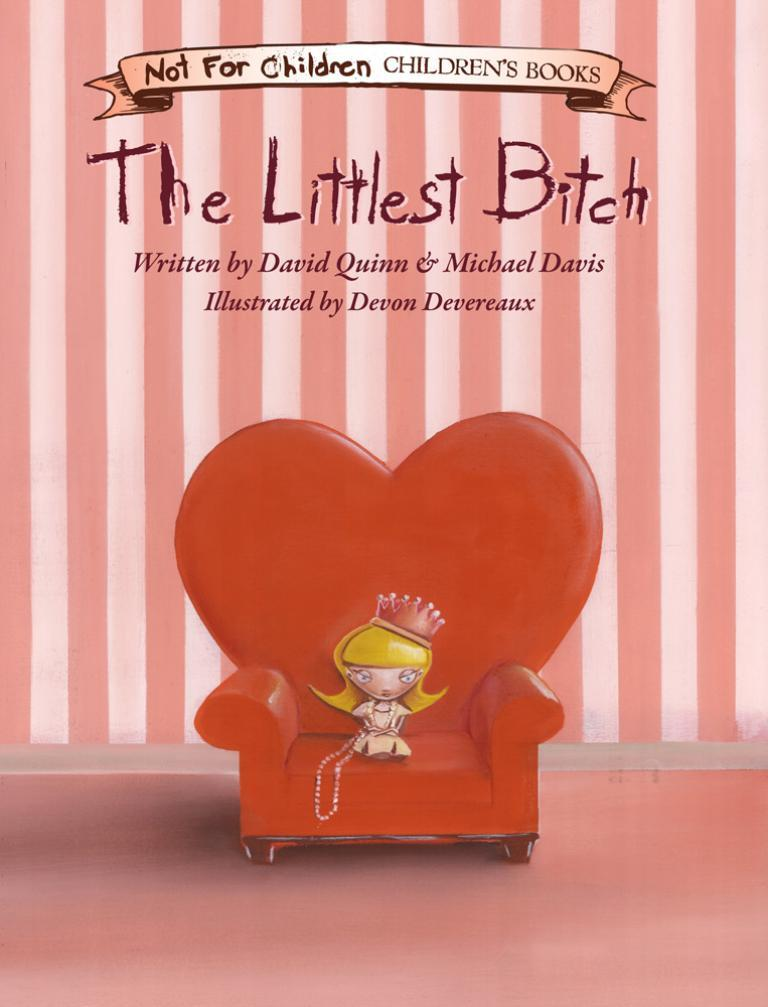What is depicted on the poster in the image? The poster features a woman sitting on a chair. What else can be seen on the poster besides the woman? There is writing on the poster. What type of ant can be seen carrying a cherry on the poster? There is no ant or cherry present on the poster; it features a woman sitting on a chair with writing. 